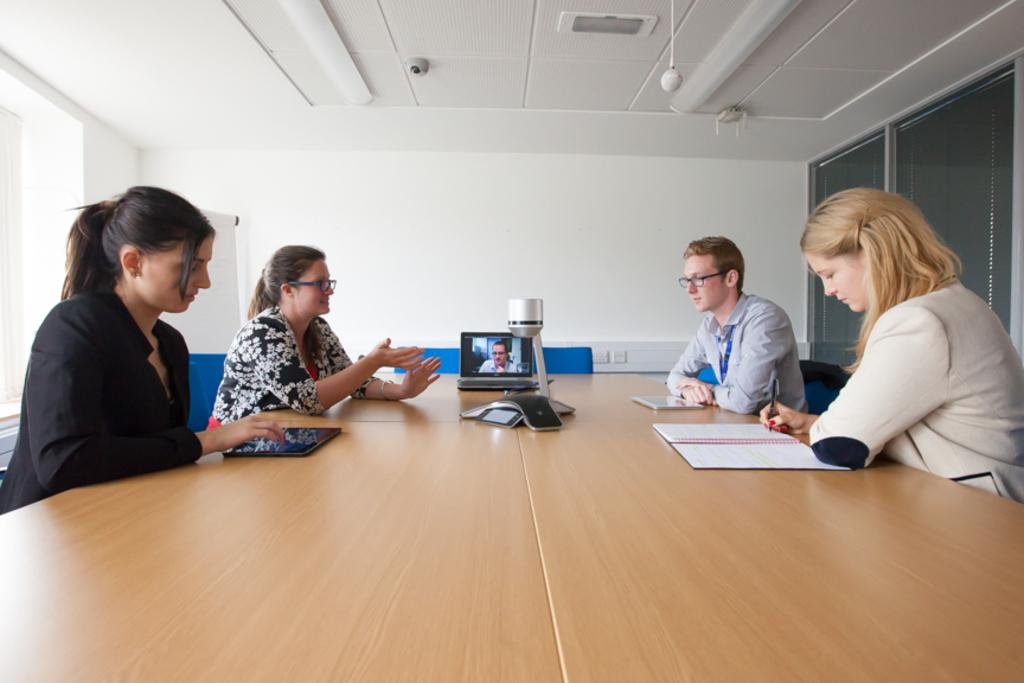How many people are sitting in the image? There are four persons sitting on chairs. What objects are on the table in the image? There is a book and a laptop on the table. What type of feather can be seen on the laptop in the image? There is no feather present on the laptop in the image. What kind of meat is being served on the table in the image? There is no meat present on the table in the image. 